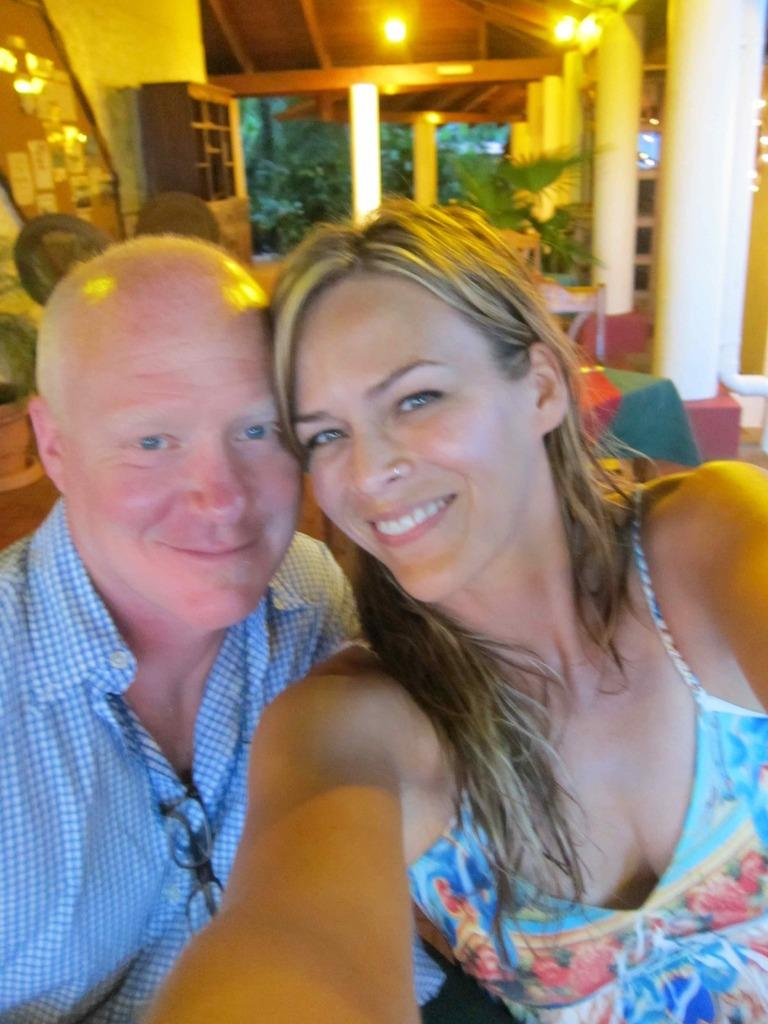How many people are present in the image? There are two persons in the image. What can be seen in the background of the image? In the background of the image, there are shelves, lights, poles, and a window. Can you describe the lighting in the image? The lighting in the image is provided by the lights visible in the background. What architectural feature can be seen in the background of the image? Poles are visible in the background of the image. What type of sea creatures can be seen swimming near the window in the image? There is no sea or sea creatures present in the image; it features two persons and various background elements. 